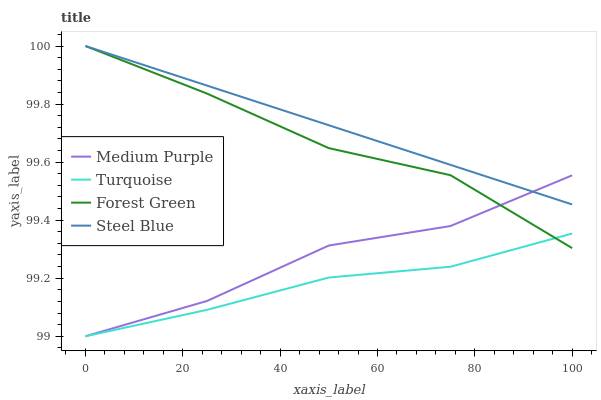Does Turquoise have the minimum area under the curve?
Answer yes or no. Yes. Does Steel Blue have the maximum area under the curve?
Answer yes or no. Yes. Does Forest Green have the minimum area under the curve?
Answer yes or no. No. Does Forest Green have the maximum area under the curve?
Answer yes or no. No. Is Steel Blue the smoothest?
Answer yes or no. Yes. Is Medium Purple the roughest?
Answer yes or no. Yes. Is Turquoise the smoothest?
Answer yes or no. No. Is Turquoise the roughest?
Answer yes or no. No. Does Forest Green have the lowest value?
Answer yes or no. No. Does Steel Blue have the highest value?
Answer yes or no. Yes. Does Turquoise have the highest value?
Answer yes or no. No. Is Turquoise less than Steel Blue?
Answer yes or no. Yes. Is Steel Blue greater than Turquoise?
Answer yes or no. Yes. Does Forest Green intersect Medium Purple?
Answer yes or no. Yes. Is Forest Green less than Medium Purple?
Answer yes or no. No. Is Forest Green greater than Medium Purple?
Answer yes or no. No. Does Turquoise intersect Steel Blue?
Answer yes or no. No. 